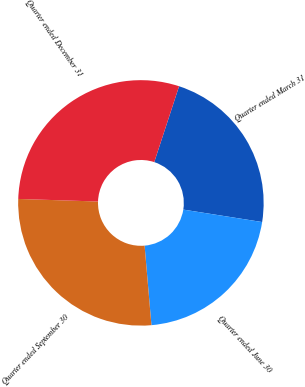Convert chart. <chart><loc_0><loc_0><loc_500><loc_500><pie_chart><fcel>Quarter ended March 31<fcel>Quarter ended June 30<fcel>Quarter ended September 30<fcel>Quarter ended December 31<nl><fcel>22.46%<fcel>21.14%<fcel>26.88%<fcel>29.52%<nl></chart> 